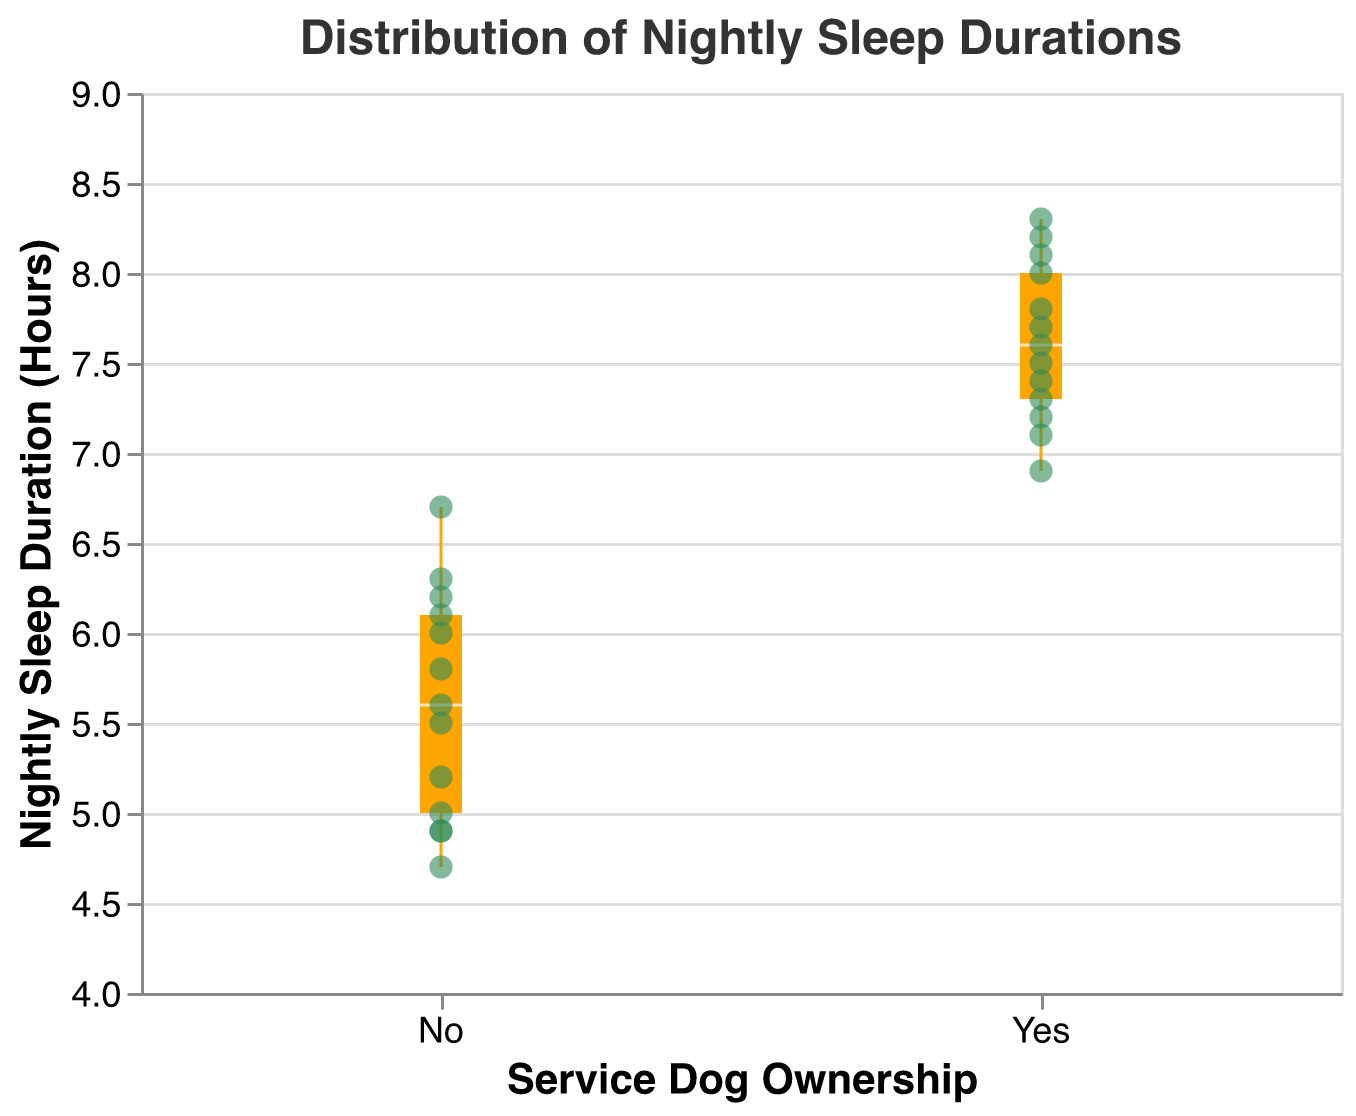What is the title of the figure? The title of the figure is typically displayed at the top. Here, the title text is "Distribution of Nightly Sleep Durations".
Answer: Distribution of Nightly Sleep Durations How many total data points are displayed on the plot? To find the number of data points, one can count the individual scatter points representing the individuals' nightly sleep durations.
Answer: 26 Which group shows a higher median nightly sleep duration? Observing the median lines in each box plot, compare their positions along the y-axis. The group with a higher median line has a higher median nightly sleep duration.
Answer: Yes What is the interquartile range (IQR) for owners with a service dog? The interquartile range is the difference between the upper quartile (75th percentile) and the lower quartile (25th percentile) of the box plot. Thus, locate these points on the y-axis for the "Yes" group and calculate the difference.
Answer: 1 What is the minimum nightly sleep duration for owners without a service dog? The minimum value is represented by the bottom whisker of the box plot for the "No" group.
Answer: 4.7 How many data points fall outside the interquartile range for owners with a service dog? To determine this, identify points that lie outside the box (between the 25th and 75th percentiles) for the "Yes" group.
Answer: 3 Which owner has the maximum nightly sleep duration, and what is it? Use the scatter points along with the tooltip feature to identify the owner with the highest y-value.
Answer: Sam, 8.3 hours How does the variability in nightly sleep durations compare between service dog owners and non-owners? Compare the length of the whiskers and the interquartile range (IQR) to evaluate which group has a larger spread of data.
Answer: Non-owners have more variability What is the average nightly sleep duration for owners without a service dog? Calculate the average by summing the nightly sleep durations of non-owners and dividing by the number of non-owners. (5.2 + 6.3 + 4.9 + 5.6 + 6.7 + 5.0 + 4.7 + 6.0 + 5.8 + 6.2 + 5.5 + 4.9 + 6.1) / 13 = 5.64
Answer: 5.64 Is there a larger outlier within the non-service dog owners? Check if any point significantly deviates from the interquartile range, usually beyond 1.5 times the IQR. Compare any such points to those in the service-dog group.
Answer: No 